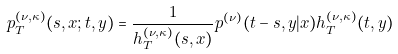<formula> <loc_0><loc_0><loc_500><loc_500>p ^ { ( \nu , \kappa ) } _ { T } ( s , x ; t , y ) = \frac { 1 } { h ^ { ( \nu , \kappa ) } _ { T } ( s , x ) } p ^ { ( \nu ) } ( t - s , y | x ) h ^ { ( \nu , \kappa ) } _ { T } ( t , y )</formula> 